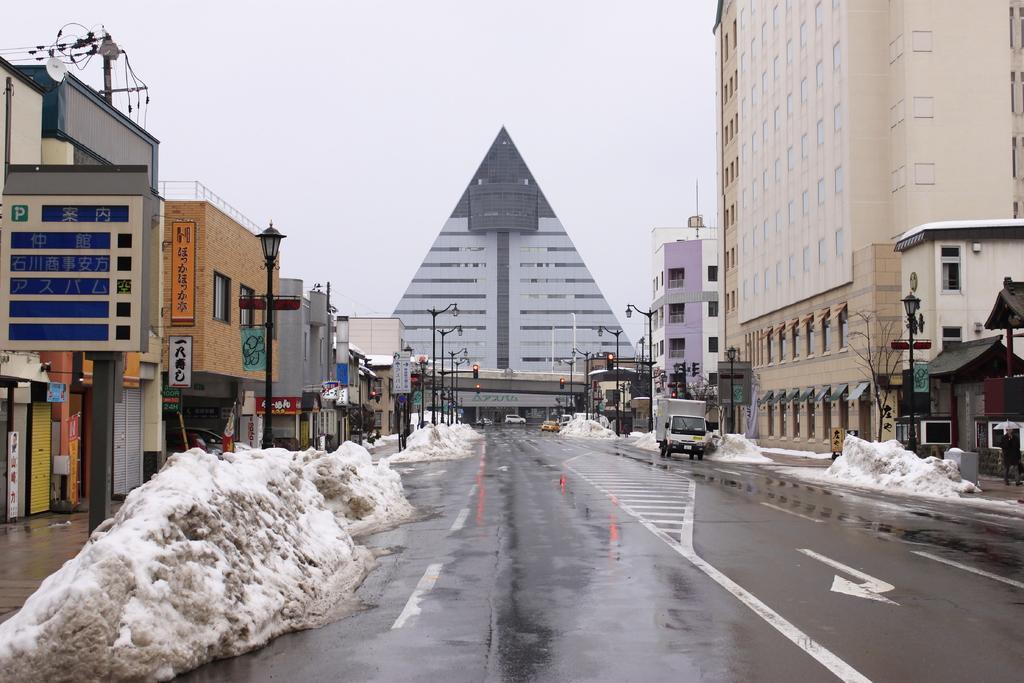Could you give a brief overview of what you see in this image? In this image I can see few vehicles on the road. On both sides of the road I can see the snow, light poles, boards and the buildings. In the background I can see one more building and the sky. 